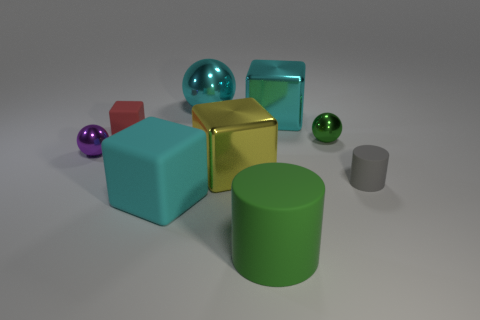What is the tiny ball that is left of the yellow object made of?
Your answer should be very brief. Metal. Does the tiny gray matte object have the same shape as the purple metal object?
Provide a short and direct response. No. How many other objects are there of the same shape as the yellow metallic object?
Your response must be concise. 3. What color is the tiny shiny ball that is on the right side of the big green matte cylinder?
Keep it short and to the point. Green. Do the cyan matte block and the gray matte cylinder have the same size?
Your answer should be compact. No. There is a cyan object on the right side of the large metal block in front of the purple thing; what is its material?
Offer a very short reply. Metal. How many tiny metallic spheres have the same color as the big matte cylinder?
Give a very brief answer. 1. Is there anything else that has the same material as the purple ball?
Provide a succinct answer. Yes. Is the number of tiny gray cylinders that are left of the purple metallic sphere less than the number of big cyan matte blocks?
Provide a short and direct response. Yes. What is the color of the cylinder on the left side of the object on the right side of the green shiny object?
Your answer should be compact. Green. 